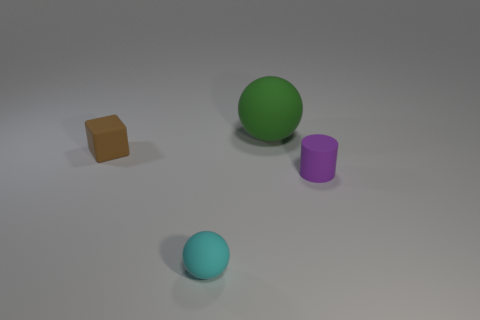What number of blocks are either purple matte objects or cyan objects?
Offer a terse response. 0. There is a sphere that is behind the tiny purple cylinder; what is its color?
Ensure brevity in your answer.  Green. What number of purple matte cylinders are the same size as the green matte sphere?
Give a very brief answer. 0. There is a tiny object that is in front of the small rubber cylinder; does it have the same shape as the object that is behind the small block?
Provide a short and direct response. Yes. There is a purple thing that is the same size as the cyan matte object; what is its shape?
Your answer should be compact. Cylinder. The green thing is what size?
Keep it short and to the point. Large. What number of tiny brown blocks are in front of the sphere that is in front of the big rubber ball that is behind the brown rubber cube?
Give a very brief answer. 0. What shape is the thing that is on the right side of the big sphere?
Your response must be concise. Cylinder. How many other things are there of the same material as the green object?
Give a very brief answer. 3. Is the large matte thing the same color as the rubber cube?
Ensure brevity in your answer.  No. 